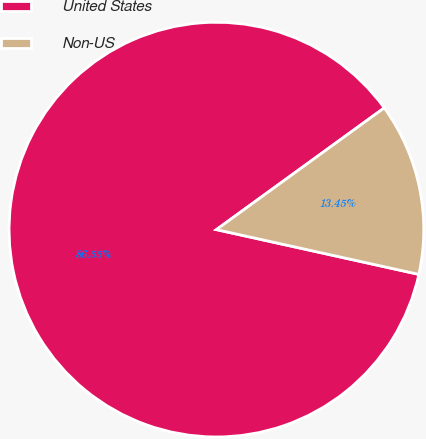<chart> <loc_0><loc_0><loc_500><loc_500><pie_chart><fcel>United States<fcel>Non-US<nl><fcel>86.55%<fcel>13.45%<nl></chart> 